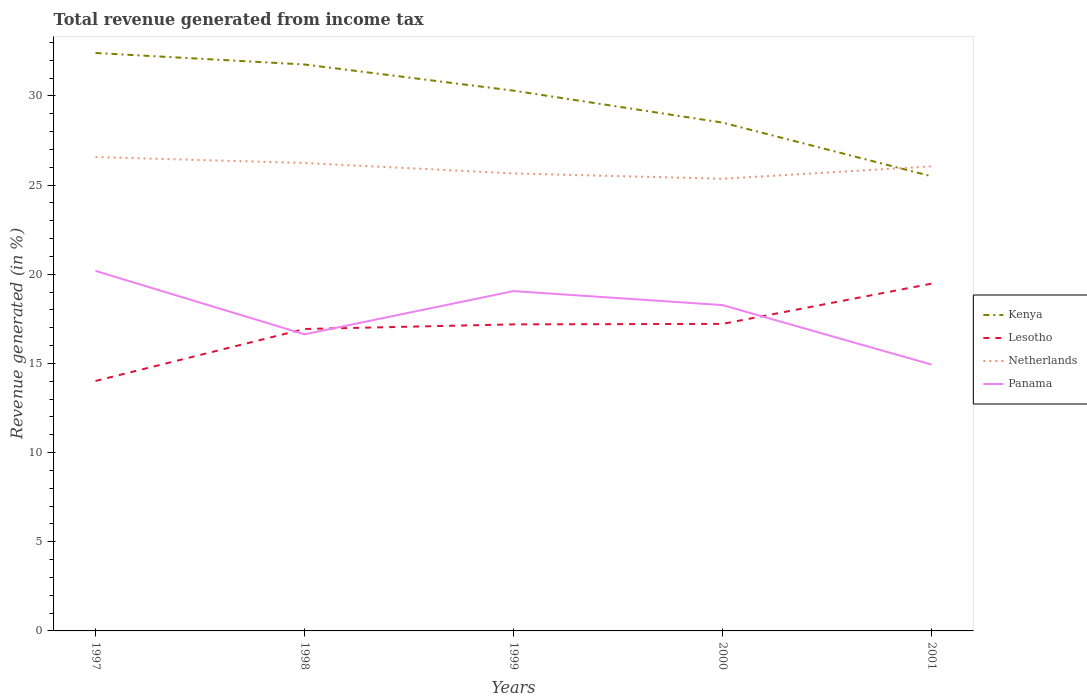How many different coloured lines are there?
Keep it short and to the point. 4. Is the number of lines equal to the number of legend labels?
Make the answer very short. Yes. Across all years, what is the maximum total revenue generated in Panama?
Provide a succinct answer. 14.93. What is the total total revenue generated in Panama in the graph?
Make the answer very short. 1.92. What is the difference between the highest and the second highest total revenue generated in Lesotho?
Keep it short and to the point. 5.45. What is the difference between the highest and the lowest total revenue generated in Panama?
Give a very brief answer. 3. Is the total revenue generated in Kenya strictly greater than the total revenue generated in Netherlands over the years?
Offer a terse response. No. How many lines are there?
Provide a short and direct response. 4. What is the difference between two consecutive major ticks on the Y-axis?
Offer a very short reply. 5. How many legend labels are there?
Give a very brief answer. 4. What is the title of the graph?
Your answer should be compact. Total revenue generated from income tax. Does "Portugal" appear as one of the legend labels in the graph?
Your response must be concise. No. What is the label or title of the Y-axis?
Your response must be concise. Revenue generated (in %). What is the Revenue generated (in %) of Kenya in 1997?
Offer a terse response. 32.41. What is the Revenue generated (in %) in Lesotho in 1997?
Keep it short and to the point. 14.02. What is the Revenue generated (in %) of Netherlands in 1997?
Your answer should be very brief. 26.57. What is the Revenue generated (in %) in Panama in 1997?
Give a very brief answer. 20.19. What is the Revenue generated (in %) in Kenya in 1998?
Offer a terse response. 31.76. What is the Revenue generated (in %) of Lesotho in 1998?
Ensure brevity in your answer.  16.93. What is the Revenue generated (in %) of Netherlands in 1998?
Keep it short and to the point. 26.24. What is the Revenue generated (in %) of Panama in 1998?
Offer a very short reply. 16.63. What is the Revenue generated (in %) of Kenya in 1999?
Your answer should be very brief. 30.29. What is the Revenue generated (in %) of Lesotho in 1999?
Offer a terse response. 17.19. What is the Revenue generated (in %) of Netherlands in 1999?
Give a very brief answer. 25.65. What is the Revenue generated (in %) in Panama in 1999?
Provide a short and direct response. 19.05. What is the Revenue generated (in %) in Kenya in 2000?
Your response must be concise. 28.5. What is the Revenue generated (in %) of Lesotho in 2000?
Your answer should be compact. 17.22. What is the Revenue generated (in %) of Netherlands in 2000?
Keep it short and to the point. 25.35. What is the Revenue generated (in %) of Panama in 2000?
Your response must be concise. 18.27. What is the Revenue generated (in %) in Kenya in 2001?
Your answer should be very brief. 25.49. What is the Revenue generated (in %) in Lesotho in 2001?
Make the answer very short. 19.47. What is the Revenue generated (in %) of Netherlands in 2001?
Provide a succinct answer. 26.05. What is the Revenue generated (in %) in Panama in 2001?
Your answer should be compact. 14.93. Across all years, what is the maximum Revenue generated (in %) in Kenya?
Offer a very short reply. 32.41. Across all years, what is the maximum Revenue generated (in %) in Lesotho?
Give a very brief answer. 19.47. Across all years, what is the maximum Revenue generated (in %) in Netherlands?
Your answer should be very brief. 26.57. Across all years, what is the maximum Revenue generated (in %) of Panama?
Your answer should be very brief. 20.19. Across all years, what is the minimum Revenue generated (in %) of Kenya?
Keep it short and to the point. 25.49. Across all years, what is the minimum Revenue generated (in %) in Lesotho?
Provide a short and direct response. 14.02. Across all years, what is the minimum Revenue generated (in %) of Netherlands?
Keep it short and to the point. 25.35. Across all years, what is the minimum Revenue generated (in %) in Panama?
Offer a terse response. 14.93. What is the total Revenue generated (in %) in Kenya in the graph?
Your answer should be compact. 148.46. What is the total Revenue generated (in %) in Lesotho in the graph?
Offer a very short reply. 84.82. What is the total Revenue generated (in %) in Netherlands in the graph?
Your answer should be very brief. 129.87. What is the total Revenue generated (in %) in Panama in the graph?
Offer a terse response. 89.08. What is the difference between the Revenue generated (in %) of Kenya in 1997 and that in 1998?
Your answer should be compact. 0.65. What is the difference between the Revenue generated (in %) of Lesotho in 1997 and that in 1998?
Your answer should be compact. -2.91. What is the difference between the Revenue generated (in %) in Netherlands in 1997 and that in 1998?
Offer a terse response. 0.33. What is the difference between the Revenue generated (in %) of Panama in 1997 and that in 1998?
Provide a short and direct response. 3.56. What is the difference between the Revenue generated (in %) in Kenya in 1997 and that in 1999?
Provide a succinct answer. 2.11. What is the difference between the Revenue generated (in %) of Lesotho in 1997 and that in 1999?
Make the answer very short. -3.17. What is the difference between the Revenue generated (in %) of Netherlands in 1997 and that in 1999?
Keep it short and to the point. 0.92. What is the difference between the Revenue generated (in %) of Panama in 1997 and that in 1999?
Your answer should be very brief. 1.13. What is the difference between the Revenue generated (in %) of Kenya in 1997 and that in 2000?
Make the answer very short. 3.9. What is the difference between the Revenue generated (in %) in Lesotho in 1997 and that in 2000?
Provide a short and direct response. -3.2. What is the difference between the Revenue generated (in %) of Netherlands in 1997 and that in 2000?
Your answer should be compact. 1.22. What is the difference between the Revenue generated (in %) of Panama in 1997 and that in 2000?
Keep it short and to the point. 1.92. What is the difference between the Revenue generated (in %) of Kenya in 1997 and that in 2001?
Provide a succinct answer. 6.91. What is the difference between the Revenue generated (in %) of Lesotho in 1997 and that in 2001?
Offer a terse response. -5.45. What is the difference between the Revenue generated (in %) of Netherlands in 1997 and that in 2001?
Offer a terse response. 0.52. What is the difference between the Revenue generated (in %) in Panama in 1997 and that in 2001?
Ensure brevity in your answer.  5.25. What is the difference between the Revenue generated (in %) of Kenya in 1998 and that in 1999?
Your response must be concise. 1.47. What is the difference between the Revenue generated (in %) of Lesotho in 1998 and that in 1999?
Your response must be concise. -0.26. What is the difference between the Revenue generated (in %) in Netherlands in 1998 and that in 1999?
Give a very brief answer. 0.59. What is the difference between the Revenue generated (in %) in Panama in 1998 and that in 1999?
Offer a very short reply. -2.42. What is the difference between the Revenue generated (in %) of Kenya in 1998 and that in 2000?
Provide a short and direct response. 3.26. What is the difference between the Revenue generated (in %) in Lesotho in 1998 and that in 2000?
Your answer should be compact. -0.29. What is the difference between the Revenue generated (in %) of Netherlands in 1998 and that in 2000?
Ensure brevity in your answer.  0.88. What is the difference between the Revenue generated (in %) in Panama in 1998 and that in 2000?
Provide a short and direct response. -1.64. What is the difference between the Revenue generated (in %) of Kenya in 1998 and that in 2001?
Provide a succinct answer. 6.27. What is the difference between the Revenue generated (in %) of Lesotho in 1998 and that in 2001?
Your answer should be compact. -2.54. What is the difference between the Revenue generated (in %) of Netherlands in 1998 and that in 2001?
Keep it short and to the point. 0.19. What is the difference between the Revenue generated (in %) in Panama in 1998 and that in 2001?
Give a very brief answer. 1.7. What is the difference between the Revenue generated (in %) in Kenya in 1999 and that in 2000?
Your answer should be very brief. 1.79. What is the difference between the Revenue generated (in %) in Lesotho in 1999 and that in 2000?
Your answer should be very brief. -0.03. What is the difference between the Revenue generated (in %) of Netherlands in 1999 and that in 2000?
Offer a terse response. 0.3. What is the difference between the Revenue generated (in %) of Panama in 1999 and that in 2000?
Your answer should be very brief. 0.78. What is the difference between the Revenue generated (in %) of Kenya in 1999 and that in 2001?
Ensure brevity in your answer.  4.8. What is the difference between the Revenue generated (in %) of Lesotho in 1999 and that in 2001?
Ensure brevity in your answer.  -2.28. What is the difference between the Revenue generated (in %) of Netherlands in 1999 and that in 2001?
Provide a succinct answer. -0.4. What is the difference between the Revenue generated (in %) of Panama in 1999 and that in 2001?
Give a very brief answer. 4.12. What is the difference between the Revenue generated (in %) in Kenya in 2000 and that in 2001?
Offer a very short reply. 3.01. What is the difference between the Revenue generated (in %) in Lesotho in 2000 and that in 2001?
Offer a very short reply. -2.26. What is the difference between the Revenue generated (in %) of Netherlands in 2000 and that in 2001?
Offer a very short reply. -0.7. What is the difference between the Revenue generated (in %) of Panama in 2000 and that in 2001?
Offer a very short reply. 3.34. What is the difference between the Revenue generated (in %) of Kenya in 1997 and the Revenue generated (in %) of Lesotho in 1998?
Make the answer very short. 15.48. What is the difference between the Revenue generated (in %) in Kenya in 1997 and the Revenue generated (in %) in Netherlands in 1998?
Offer a very short reply. 6.17. What is the difference between the Revenue generated (in %) of Kenya in 1997 and the Revenue generated (in %) of Panama in 1998?
Provide a succinct answer. 15.78. What is the difference between the Revenue generated (in %) in Lesotho in 1997 and the Revenue generated (in %) in Netherlands in 1998?
Your answer should be very brief. -12.22. What is the difference between the Revenue generated (in %) of Lesotho in 1997 and the Revenue generated (in %) of Panama in 1998?
Give a very brief answer. -2.61. What is the difference between the Revenue generated (in %) of Netherlands in 1997 and the Revenue generated (in %) of Panama in 1998?
Your answer should be very brief. 9.94. What is the difference between the Revenue generated (in %) in Kenya in 1997 and the Revenue generated (in %) in Lesotho in 1999?
Provide a succinct answer. 15.22. What is the difference between the Revenue generated (in %) of Kenya in 1997 and the Revenue generated (in %) of Netherlands in 1999?
Keep it short and to the point. 6.75. What is the difference between the Revenue generated (in %) in Kenya in 1997 and the Revenue generated (in %) in Panama in 1999?
Give a very brief answer. 13.35. What is the difference between the Revenue generated (in %) in Lesotho in 1997 and the Revenue generated (in %) in Netherlands in 1999?
Make the answer very short. -11.64. What is the difference between the Revenue generated (in %) of Lesotho in 1997 and the Revenue generated (in %) of Panama in 1999?
Provide a succinct answer. -5.04. What is the difference between the Revenue generated (in %) in Netherlands in 1997 and the Revenue generated (in %) in Panama in 1999?
Provide a short and direct response. 7.52. What is the difference between the Revenue generated (in %) in Kenya in 1997 and the Revenue generated (in %) in Lesotho in 2000?
Give a very brief answer. 15.19. What is the difference between the Revenue generated (in %) in Kenya in 1997 and the Revenue generated (in %) in Netherlands in 2000?
Your answer should be very brief. 7.05. What is the difference between the Revenue generated (in %) of Kenya in 1997 and the Revenue generated (in %) of Panama in 2000?
Keep it short and to the point. 14.14. What is the difference between the Revenue generated (in %) in Lesotho in 1997 and the Revenue generated (in %) in Netherlands in 2000?
Provide a succinct answer. -11.34. What is the difference between the Revenue generated (in %) of Lesotho in 1997 and the Revenue generated (in %) of Panama in 2000?
Provide a short and direct response. -4.25. What is the difference between the Revenue generated (in %) in Netherlands in 1997 and the Revenue generated (in %) in Panama in 2000?
Provide a short and direct response. 8.3. What is the difference between the Revenue generated (in %) in Kenya in 1997 and the Revenue generated (in %) in Lesotho in 2001?
Keep it short and to the point. 12.94. What is the difference between the Revenue generated (in %) of Kenya in 1997 and the Revenue generated (in %) of Netherlands in 2001?
Provide a short and direct response. 6.36. What is the difference between the Revenue generated (in %) of Kenya in 1997 and the Revenue generated (in %) of Panama in 2001?
Keep it short and to the point. 17.47. What is the difference between the Revenue generated (in %) of Lesotho in 1997 and the Revenue generated (in %) of Netherlands in 2001?
Ensure brevity in your answer.  -12.03. What is the difference between the Revenue generated (in %) of Lesotho in 1997 and the Revenue generated (in %) of Panama in 2001?
Ensure brevity in your answer.  -0.92. What is the difference between the Revenue generated (in %) in Netherlands in 1997 and the Revenue generated (in %) in Panama in 2001?
Provide a short and direct response. 11.64. What is the difference between the Revenue generated (in %) of Kenya in 1998 and the Revenue generated (in %) of Lesotho in 1999?
Give a very brief answer. 14.57. What is the difference between the Revenue generated (in %) in Kenya in 1998 and the Revenue generated (in %) in Netherlands in 1999?
Offer a very short reply. 6.11. What is the difference between the Revenue generated (in %) in Kenya in 1998 and the Revenue generated (in %) in Panama in 1999?
Keep it short and to the point. 12.71. What is the difference between the Revenue generated (in %) of Lesotho in 1998 and the Revenue generated (in %) of Netherlands in 1999?
Give a very brief answer. -8.72. What is the difference between the Revenue generated (in %) in Lesotho in 1998 and the Revenue generated (in %) in Panama in 1999?
Provide a short and direct response. -2.13. What is the difference between the Revenue generated (in %) of Netherlands in 1998 and the Revenue generated (in %) of Panama in 1999?
Your response must be concise. 7.18. What is the difference between the Revenue generated (in %) in Kenya in 1998 and the Revenue generated (in %) in Lesotho in 2000?
Make the answer very short. 14.55. What is the difference between the Revenue generated (in %) in Kenya in 1998 and the Revenue generated (in %) in Netherlands in 2000?
Offer a terse response. 6.41. What is the difference between the Revenue generated (in %) in Kenya in 1998 and the Revenue generated (in %) in Panama in 2000?
Provide a succinct answer. 13.49. What is the difference between the Revenue generated (in %) in Lesotho in 1998 and the Revenue generated (in %) in Netherlands in 2000?
Your response must be concise. -8.42. What is the difference between the Revenue generated (in %) in Lesotho in 1998 and the Revenue generated (in %) in Panama in 2000?
Provide a succinct answer. -1.34. What is the difference between the Revenue generated (in %) of Netherlands in 1998 and the Revenue generated (in %) of Panama in 2000?
Your answer should be compact. 7.97. What is the difference between the Revenue generated (in %) of Kenya in 1998 and the Revenue generated (in %) of Lesotho in 2001?
Provide a short and direct response. 12.29. What is the difference between the Revenue generated (in %) in Kenya in 1998 and the Revenue generated (in %) in Netherlands in 2001?
Ensure brevity in your answer.  5.71. What is the difference between the Revenue generated (in %) of Kenya in 1998 and the Revenue generated (in %) of Panama in 2001?
Provide a short and direct response. 16.83. What is the difference between the Revenue generated (in %) of Lesotho in 1998 and the Revenue generated (in %) of Netherlands in 2001?
Give a very brief answer. -9.12. What is the difference between the Revenue generated (in %) in Lesotho in 1998 and the Revenue generated (in %) in Panama in 2001?
Ensure brevity in your answer.  2. What is the difference between the Revenue generated (in %) in Netherlands in 1998 and the Revenue generated (in %) in Panama in 2001?
Offer a terse response. 11.3. What is the difference between the Revenue generated (in %) in Kenya in 1999 and the Revenue generated (in %) in Lesotho in 2000?
Ensure brevity in your answer.  13.08. What is the difference between the Revenue generated (in %) in Kenya in 1999 and the Revenue generated (in %) in Netherlands in 2000?
Your answer should be compact. 4.94. What is the difference between the Revenue generated (in %) of Kenya in 1999 and the Revenue generated (in %) of Panama in 2000?
Your answer should be very brief. 12.02. What is the difference between the Revenue generated (in %) of Lesotho in 1999 and the Revenue generated (in %) of Netherlands in 2000?
Ensure brevity in your answer.  -8.17. What is the difference between the Revenue generated (in %) in Lesotho in 1999 and the Revenue generated (in %) in Panama in 2000?
Your answer should be compact. -1.08. What is the difference between the Revenue generated (in %) of Netherlands in 1999 and the Revenue generated (in %) of Panama in 2000?
Provide a succinct answer. 7.38. What is the difference between the Revenue generated (in %) of Kenya in 1999 and the Revenue generated (in %) of Lesotho in 2001?
Your response must be concise. 10.82. What is the difference between the Revenue generated (in %) of Kenya in 1999 and the Revenue generated (in %) of Netherlands in 2001?
Offer a terse response. 4.24. What is the difference between the Revenue generated (in %) in Kenya in 1999 and the Revenue generated (in %) in Panama in 2001?
Your answer should be very brief. 15.36. What is the difference between the Revenue generated (in %) in Lesotho in 1999 and the Revenue generated (in %) in Netherlands in 2001?
Your answer should be compact. -8.86. What is the difference between the Revenue generated (in %) in Lesotho in 1999 and the Revenue generated (in %) in Panama in 2001?
Ensure brevity in your answer.  2.25. What is the difference between the Revenue generated (in %) in Netherlands in 1999 and the Revenue generated (in %) in Panama in 2001?
Make the answer very short. 10.72. What is the difference between the Revenue generated (in %) in Kenya in 2000 and the Revenue generated (in %) in Lesotho in 2001?
Provide a short and direct response. 9.03. What is the difference between the Revenue generated (in %) of Kenya in 2000 and the Revenue generated (in %) of Netherlands in 2001?
Ensure brevity in your answer.  2.45. What is the difference between the Revenue generated (in %) of Kenya in 2000 and the Revenue generated (in %) of Panama in 2001?
Make the answer very short. 13.57. What is the difference between the Revenue generated (in %) of Lesotho in 2000 and the Revenue generated (in %) of Netherlands in 2001?
Offer a very short reply. -8.84. What is the difference between the Revenue generated (in %) in Lesotho in 2000 and the Revenue generated (in %) in Panama in 2001?
Your response must be concise. 2.28. What is the difference between the Revenue generated (in %) in Netherlands in 2000 and the Revenue generated (in %) in Panama in 2001?
Offer a very short reply. 10.42. What is the average Revenue generated (in %) in Kenya per year?
Your answer should be compact. 29.69. What is the average Revenue generated (in %) of Lesotho per year?
Provide a short and direct response. 16.96. What is the average Revenue generated (in %) of Netherlands per year?
Provide a succinct answer. 25.97. What is the average Revenue generated (in %) in Panama per year?
Your answer should be compact. 17.82. In the year 1997, what is the difference between the Revenue generated (in %) in Kenya and Revenue generated (in %) in Lesotho?
Your answer should be very brief. 18.39. In the year 1997, what is the difference between the Revenue generated (in %) of Kenya and Revenue generated (in %) of Netherlands?
Your answer should be compact. 5.84. In the year 1997, what is the difference between the Revenue generated (in %) in Kenya and Revenue generated (in %) in Panama?
Your answer should be very brief. 12.22. In the year 1997, what is the difference between the Revenue generated (in %) in Lesotho and Revenue generated (in %) in Netherlands?
Offer a very short reply. -12.55. In the year 1997, what is the difference between the Revenue generated (in %) in Lesotho and Revenue generated (in %) in Panama?
Offer a very short reply. -6.17. In the year 1997, what is the difference between the Revenue generated (in %) in Netherlands and Revenue generated (in %) in Panama?
Provide a succinct answer. 6.38. In the year 1998, what is the difference between the Revenue generated (in %) in Kenya and Revenue generated (in %) in Lesotho?
Offer a very short reply. 14.83. In the year 1998, what is the difference between the Revenue generated (in %) of Kenya and Revenue generated (in %) of Netherlands?
Ensure brevity in your answer.  5.52. In the year 1998, what is the difference between the Revenue generated (in %) of Kenya and Revenue generated (in %) of Panama?
Ensure brevity in your answer.  15.13. In the year 1998, what is the difference between the Revenue generated (in %) of Lesotho and Revenue generated (in %) of Netherlands?
Keep it short and to the point. -9.31. In the year 1998, what is the difference between the Revenue generated (in %) in Lesotho and Revenue generated (in %) in Panama?
Offer a very short reply. 0.3. In the year 1998, what is the difference between the Revenue generated (in %) of Netherlands and Revenue generated (in %) of Panama?
Ensure brevity in your answer.  9.61. In the year 1999, what is the difference between the Revenue generated (in %) in Kenya and Revenue generated (in %) in Lesotho?
Keep it short and to the point. 13.11. In the year 1999, what is the difference between the Revenue generated (in %) in Kenya and Revenue generated (in %) in Netherlands?
Offer a very short reply. 4.64. In the year 1999, what is the difference between the Revenue generated (in %) in Kenya and Revenue generated (in %) in Panama?
Give a very brief answer. 11.24. In the year 1999, what is the difference between the Revenue generated (in %) of Lesotho and Revenue generated (in %) of Netherlands?
Give a very brief answer. -8.46. In the year 1999, what is the difference between the Revenue generated (in %) in Lesotho and Revenue generated (in %) in Panama?
Your response must be concise. -1.87. In the year 1999, what is the difference between the Revenue generated (in %) in Netherlands and Revenue generated (in %) in Panama?
Keep it short and to the point. 6.6. In the year 2000, what is the difference between the Revenue generated (in %) of Kenya and Revenue generated (in %) of Lesotho?
Your answer should be very brief. 11.29. In the year 2000, what is the difference between the Revenue generated (in %) in Kenya and Revenue generated (in %) in Netherlands?
Your answer should be compact. 3.15. In the year 2000, what is the difference between the Revenue generated (in %) of Kenya and Revenue generated (in %) of Panama?
Offer a very short reply. 10.23. In the year 2000, what is the difference between the Revenue generated (in %) of Lesotho and Revenue generated (in %) of Netherlands?
Give a very brief answer. -8.14. In the year 2000, what is the difference between the Revenue generated (in %) in Lesotho and Revenue generated (in %) in Panama?
Your response must be concise. -1.05. In the year 2000, what is the difference between the Revenue generated (in %) in Netherlands and Revenue generated (in %) in Panama?
Offer a very short reply. 7.08. In the year 2001, what is the difference between the Revenue generated (in %) of Kenya and Revenue generated (in %) of Lesotho?
Offer a very short reply. 6.02. In the year 2001, what is the difference between the Revenue generated (in %) of Kenya and Revenue generated (in %) of Netherlands?
Keep it short and to the point. -0.56. In the year 2001, what is the difference between the Revenue generated (in %) in Kenya and Revenue generated (in %) in Panama?
Offer a terse response. 10.56. In the year 2001, what is the difference between the Revenue generated (in %) in Lesotho and Revenue generated (in %) in Netherlands?
Your response must be concise. -6.58. In the year 2001, what is the difference between the Revenue generated (in %) in Lesotho and Revenue generated (in %) in Panama?
Offer a very short reply. 4.54. In the year 2001, what is the difference between the Revenue generated (in %) in Netherlands and Revenue generated (in %) in Panama?
Give a very brief answer. 11.12. What is the ratio of the Revenue generated (in %) in Kenya in 1997 to that in 1998?
Keep it short and to the point. 1.02. What is the ratio of the Revenue generated (in %) in Lesotho in 1997 to that in 1998?
Your response must be concise. 0.83. What is the ratio of the Revenue generated (in %) of Netherlands in 1997 to that in 1998?
Ensure brevity in your answer.  1.01. What is the ratio of the Revenue generated (in %) in Panama in 1997 to that in 1998?
Your answer should be very brief. 1.21. What is the ratio of the Revenue generated (in %) of Kenya in 1997 to that in 1999?
Your answer should be compact. 1.07. What is the ratio of the Revenue generated (in %) of Lesotho in 1997 to that in 1999?
Your response must be concise. 0.82. What is the ratio of the Revenue generated (in %) of Netherlands in 1997 to that in 1999?
Provide a short and direct response. 1.04. What is the ratio of the Revenue generated (in %) in Panama in 1997 to that in 1999?
Your answer should be compact. 1.06. What is the ratio of the Revenue generated (in %) in Kenya in 1997 to that in 2000?
Your answer should be very brief. 1.14. What is the ratio of the Revenue generated (in %) of Lesotho in 1997 to that in 2000?
Keep it short and to the point. 0.81. What is the ratio of the Revenue generated (in %) in Netherlands in 1997 to that in 2000?
Offer a terse response. 1.05. What is the ratio of the Revenue generated (in %) in Panama in 1997 to that in 2000?
Offer a very short reply. 1.1. What is the ratio of the Revenue generated (in %) of Kenya in 1997 to that in 2001?
Give a very brief answer. 1.27. What is the ratio of the Revenue generated (in %) in Lesotho in 1997 to that in 2001?
Your answer should be compact. 0.72. What is the ratio of the Revenue generated (in %) of Panama in 1997 to that in 2001?
Your answer should be very brief. 1.35. What is the ratio of the Revenue generated (in %) of Kenya in 1998 to that in 1999?
Make the answer very short. 1.05. What is the ratio of the Revenue generated (in %) in Lesotho in 1998 to that in 1999?
Ensure brevity in your answer.  0.98. What is the ratio of the Revenue generated (in %) in Netherlands in 1998 to that in 1999?
Your answer should be very brief. 1.02. What is the ratio of the Revenue generated (in %) of Panama in 1998 to that in 1999?
Offer a very short reply. 0.87. What is the ratio of the Revenue generated (in %) of Kenya in 1998 to that in 2000?
Ensure brevity in your answer.  1.11. What is the ratio of the Revenue generated (in %) in Lesotho in 1998 to that in 2000?
Give a very brief answer. 0.98. What is the ratio of the Revenue generated (in %) in Netherlands in 1998 to that in 2000?
Provide a short and direct response. 1.03. What is the ratio of the Revenue generated (in %) of Panama in 1998 to that in 2000?
Provide a short and direct response. 0.91. What is the ratio of the Revenue generated (in %) of Kenya in 1998 to that in 2001?
Provide a succinct answer. 1.25. What is the ratio of the Revenue generated (in %) of Lesotho in 1998 to that in 2001?
Provide a short and direct response. 0.87. What is the ratio of the Revenue generated (in %) in Panama in 1998 to that in 2001?
Your answer should be compact. 1.11. What is the ratio of the Revenue generated (in %) of Kenya in 1999 to that in 2000?
Your answer should be very brief. 1.06. What is the ratio of the Revenue generated (in %) of Lesotho in 1999 to that in 2000?
Provide a succinct answer. 1. What is the ratio of the Revenue generated (in %) in Netherlands in 1999 to that in 2000?
Give a very brief answer. 1.01. What is the ratio of the Revenue generated (in %) of Panama in 1999 to that in 2000?
Your answer should be very brief. 1.04. What is the ratio of the Revenue generated (in %) in Kenya in 1999 to that in 2001?
Make the answer very short. 1.19. What is the ratio of the Revenue generated (in %) of Lesotho in 1999 to that in 2001?
Your answer should be compact. 0.88. What is the ratio of the Revenue generated (in %) in Netherlands in 1999 to that in 2001?
Offer a very short reply. 0.98. What is the ratio of the Revenue generated (in %) in Panama in 1999 to that in 2001?
Provide a short and direct response. 1.28. What is the ratio of the Revenue generated (in %) in Kenya in 2000 to that in 2001?
Provide a short and direct response. 1.12. What is the ratio of the Revenue generated (in %) of Lesotho in 2000 to that in 2001?
Provide a short and direct response. 0.88. What is the ratio of the Revenue generated (in %) in Netherlands in 2000 to that in 2001?
Your answer should be very brief. 0.97. What is the ratio of the Revenue generated (in %) in Panama in 2000 to that in 2001?
Keep it short and to the point. 1.22. What is the difference between the highest and the second highest Revenue generated (in %) of Kenya?
Make the answer very short. 0.65. What is the difference between the highest and the second highest Revenue generated (in %) in Lesotho?
Make the answer very short. 2.26. What is the difference between the highest and the second highest Revenue generated (in %) of Netherlands?
Provide a short and direct response. 0.33. What is the difference between the highest and the second highest Revenue generated (in %) of Panama?
Keep it short and to the point. 1.13. What is the difference between the highest and the lowest Revenue generated (in %) in Kenya?
Keep it short and to the point. 6.91. What is the difference between the highest and the lowest Revenue generated (in %) of Lesotho?
Give a very brief answer. 5.45. What is the difference between the highest and the lowest Revenue generated (in %) in Netherlands?
Ensure brevity in your answer.  1.22. What is the difference between the highest and the lowest Revenue generated (in %) in Panama?
Keep it short and to the point. 5.25. 